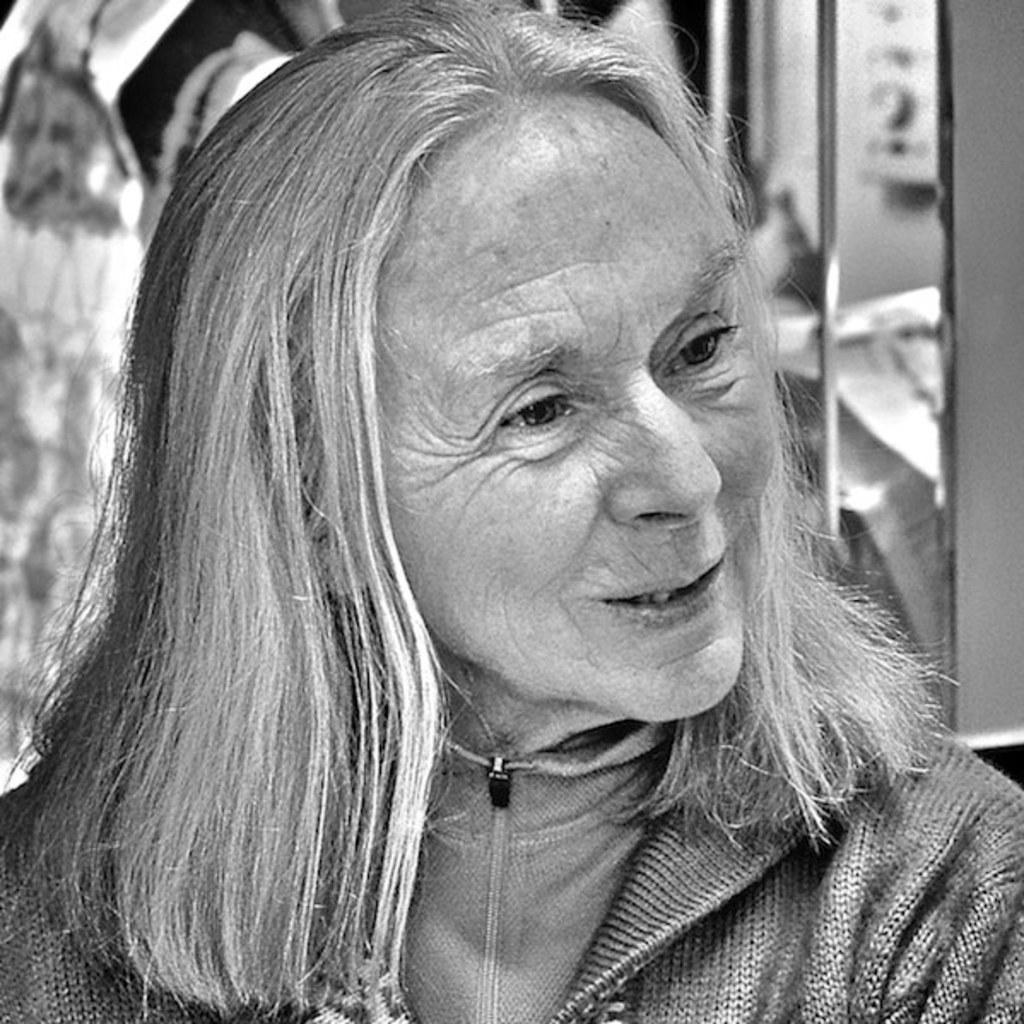Could you give a brief overview of what you see in this image? This is a zoomed in picture. In the foreground there is a person seems to be talking and we can see the wrinkles on the face of a person. In the background there are some objects. k 